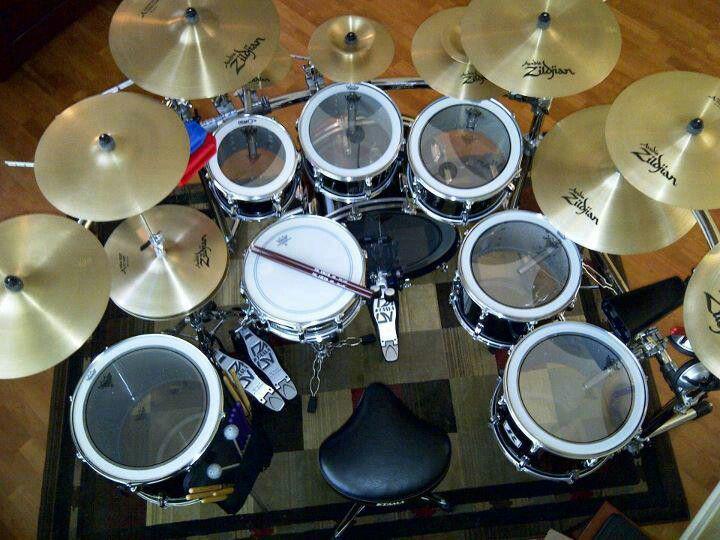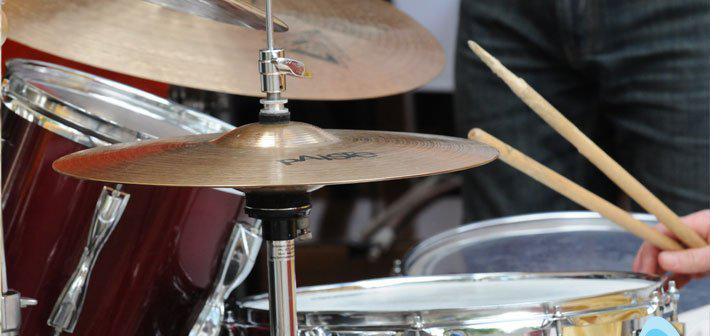The first image is the image on the left, the second image is the image on the right. For the images shown, is this caption "At least one image includes a hand holding a drum stick over the flat top of a drum." true? Answer yes or no. Yes. 